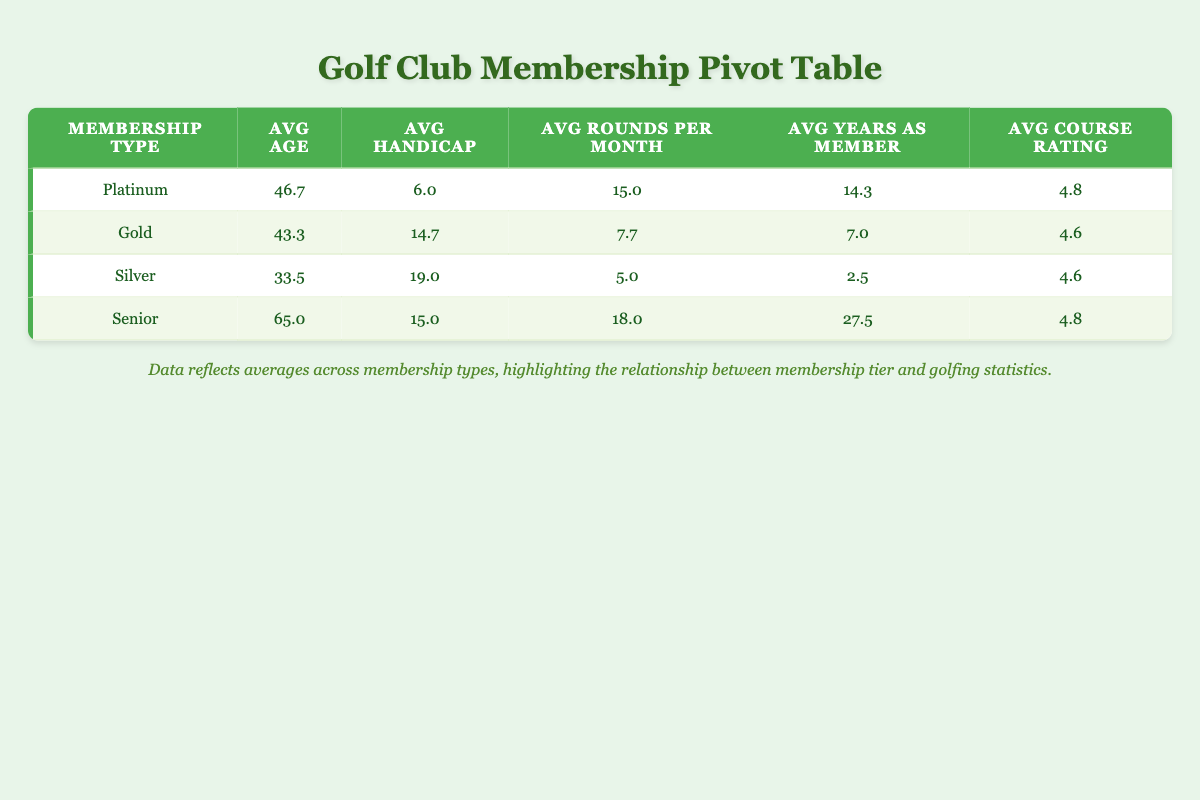What is the average age of Platinum members? To find the average age of Platinum members, we look at the ages of John Smith (52), Sarah Martinez (41), and David Wilson (47). Adding these together gives us 52 + 41 + 47 = 140. Since there are three Platinum members, the average age is calculated as 140/3 = 46.7.
Answer: 46.7 Which membership type has the highest average handicap? The table shows that Silver members have an average handicap of 19.0, which is higher than the other membership types: Platinum (6.0), Gold (14.7), and Senior (15.0). Thus, Silver members have the highest average handicap.
Answer: Silver What is the average number of rounds played per month by Gold members? The average rounds played per month by Gold members are derived from Lisa Thompson (10), Emily Johnson (8), and Emma Davis (5). Adding these values gives 10 + 8 + 5 = 23. There are three Gold members, so the average is 23/3 = 7.7.
Answer: 7.7 True or False: The average course rating for Silver members is higher than for Gold members. Looking at the table, the average course rating for Silver members is 4.6, and for Gold members, it is also 4.6. Since they are equal, the statement is false.
Answer: False What is the difference in the average years as a member between Senior and Platinum members? Average years as members for Seniors is 27.5 and for Platinum is 14.3. To find the difference, we subtract the average for Platinum from that of Senior: 27.5 - 14.3 = 13.2.
Answer: 13.2 Which membership type has the best average course rating? The average course ratings are as follows: Platinum (4.8), Gold (4.6), Silver (4.6), and Senior (4.8). Since both Platinum and Senior have the highest average course rating at 4.8, they are tied for the best rating.
Answer: Platinum and Senior If all members were combined, what would be the overall average age? We add the ages of all members: 52 + 34 + 68 + 41 + 29 + 55 + 47 + 38 + 62 + 31 =  467. There are 10 members, so the overall average age is 467/10 = 46.7.
Answer: 46.7 How many more average rounds per month do Senior members play compared to Silver members? The average rounds per month for Seniors is 18.0, and for Silver members, it is 5.0. The difference is calculated as 18.0 - 5.0 = 13.0.
Answer: 13.0 What percentage of the members are Female? There are 4 female members (Emily, Sarah, Lisa, Jessica) out of a total of 10 members. The percentage is calculated as (4/10) * 100 = 40%.
Answer: 40% 